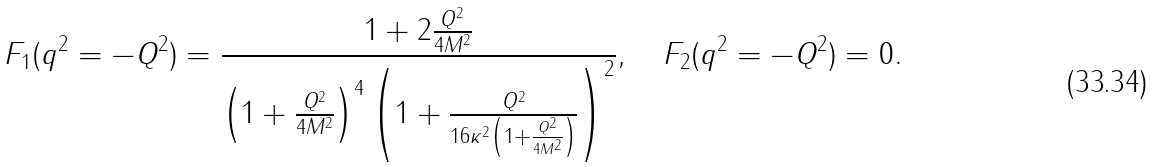Convert formula to latex. <formula><loc_0><loc_0><loc_500><loc_500>F _ { 1 } ( q ^ { 2 } = - Q ^ { 2 } ) = \frac { 1 + 2 \frac { Q ^ { 2 } } { 4 M ^ { 2 } } } { \left ( 1 + \frac { Q ^ { 2 } } { 4 M ^ { 2 } } \right ) ^ { 4 } \left ( 1 + \frac { Q ^ { 2 } } { 1 6 \kappa ^ { 2 } \left ( 1 + \frac { Q ^ { 2 } } { 4 M ^ { 2 } } \right ) } \right ) ^ { 2 } } , \quad F _ { 2 } ( q ^ { 2 } = - Q ^ { 2 } ) = 0 .</formula> 